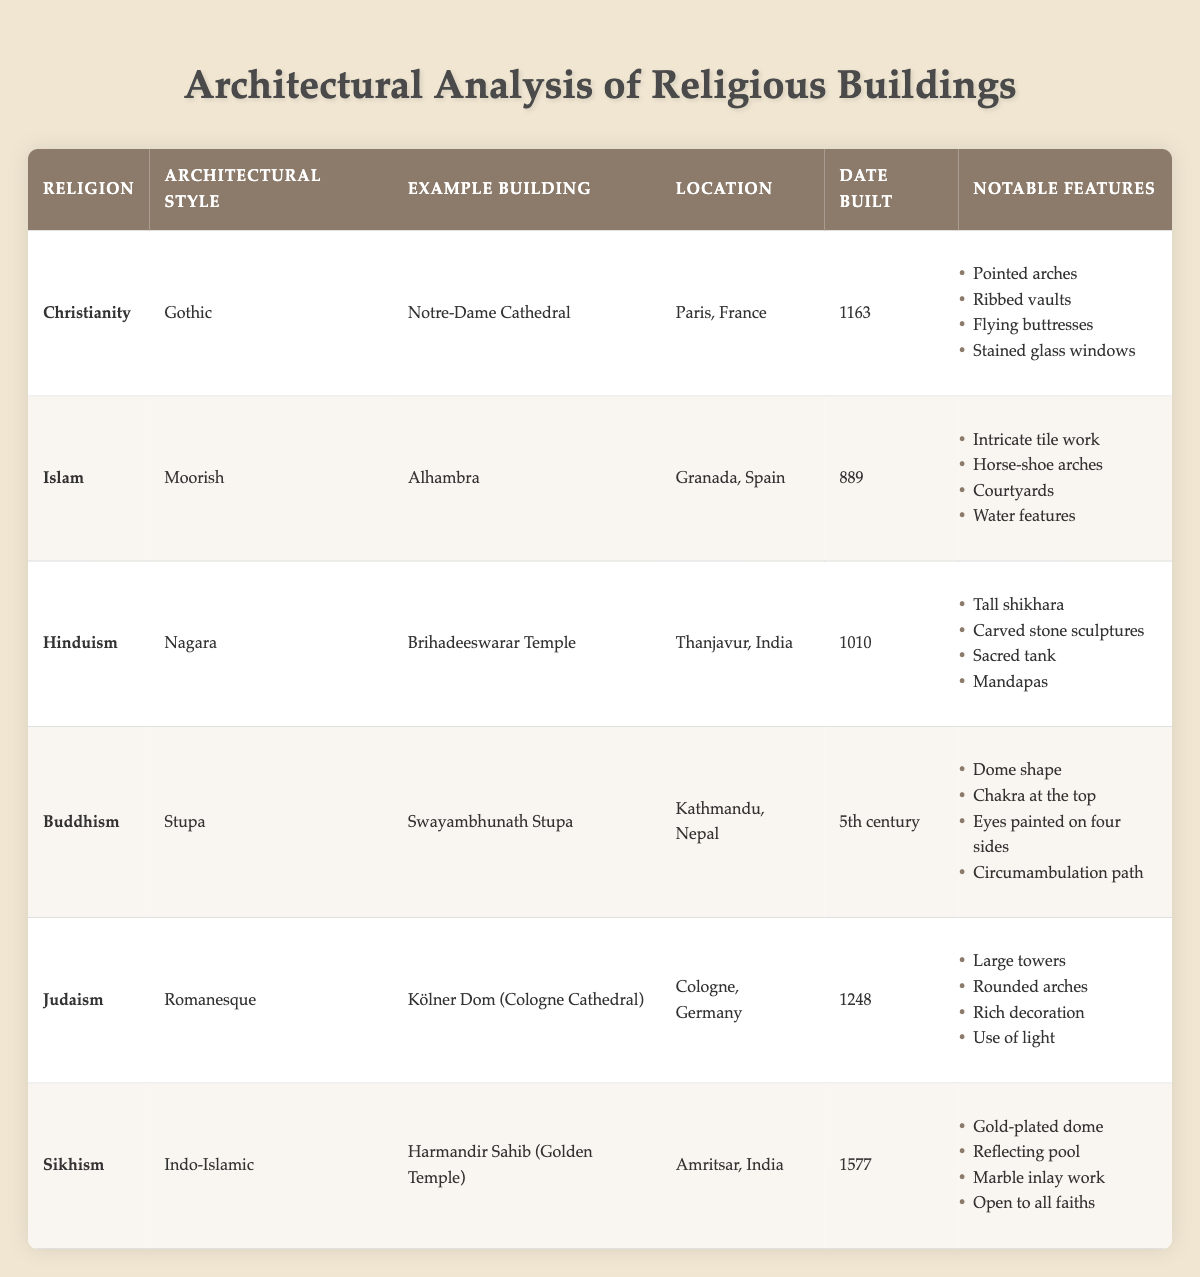What architectural style is associated with the Harmandir Sahib? The table indicates that the architectural style for the Harmandir Sahib (Golden Temple) is Indo-Islamic.
Answer: Indo-Islamic Which building represents Gothic architecture in Christianity? According to the table, the Notre-Dame Cathedral in Paris, France is the example building for Gothic architecture in Christianity.
Answer: Notre-Dame Cathedral What notable feature is common in both the Alhambra and the Harmandir Sahib? Both the Alhambra and the Harmandir Sahib have notable features related to water; the Alhambra has water features, while the Harmandir Sahib has a reflecting pool.
Answer: True How many religious buildings listed in the table were built before 1200? The buildings built before 1200 include Alhambra (889), Brihadeeswarar Temple (1010), and Notre-Dame Cathedral (1163), resulting in a total of three buildings.
Answer: 3 Which religion has the most notable features listed in the table? To determine this, we count the notable features for each religion: Christianity (4), Islam (4), Hinduism (4), Buddhism (4), Judaism (4), Sikhism (4). Each has the same number, so they are tied.
Answer: None, all have an equal number (4) Is the Swayambhunath Stupa older than the Kölner Dom? The Swayambhunath Stupa was built in the 5th century, while the Kölner Dom was completed in 1248. Thus, Swayambhunath is significantly older than Kölner Dom.
Answer: Yes How many of the buildings are located in India and what is their architectural style? The table shows two buildings in India: Brihadeeswarar Temple, which has Nagara architectural style, and Harmandir Sahib, which has Indo-Islamic architectural style.
Answer: 2; Nagara, Indo-Islamic 